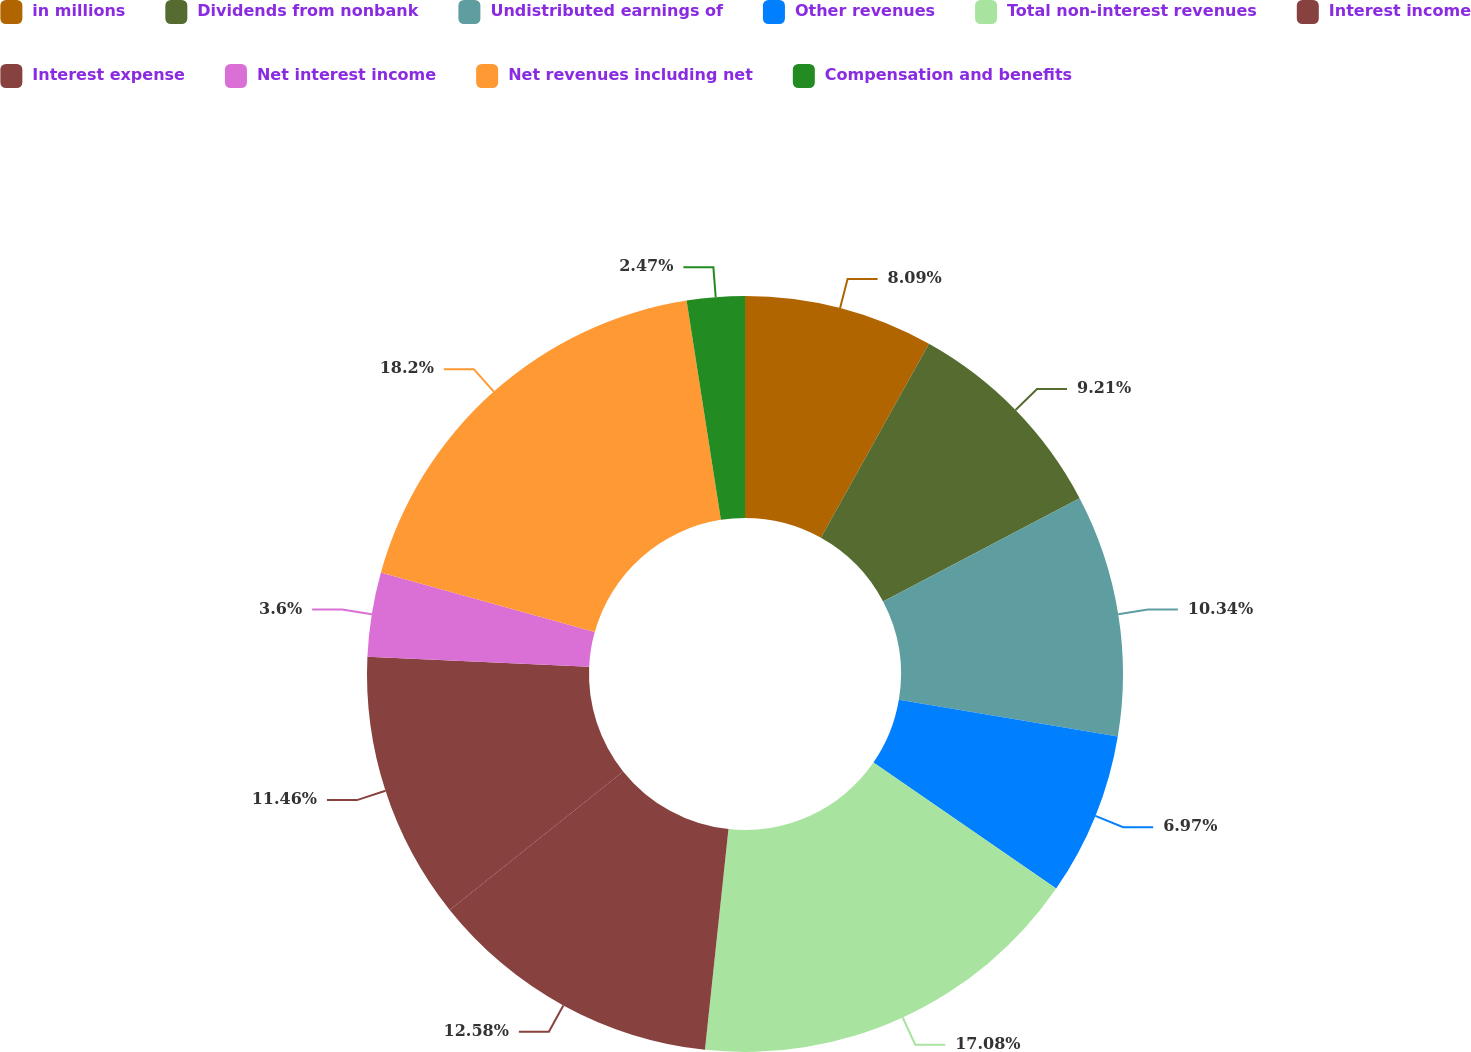Convert chart to OTSL. <chart><loc_0><loc_0><loc_500><loc_500><pie_chart><fcel>in millions<fcel>Dividends from nonbank<fcel>Undistributed earnings of<fcel>Other revenues<fcel>Total non-interest revenues<fcel>Interest income<fcel>Interest expense<fcel>Net interest income<fcel>Net revenues including net<fcel>Compensation and benefits<nl><fcel>8.09%<fcel>9.21%<fcel>10.34%<fcel>6.97%<fcel>17.08%<fcel>12.58%<fcel>11.46%<fcel>3.6%<fcel>18.2%<fcel>2.47%<nl></chart> 